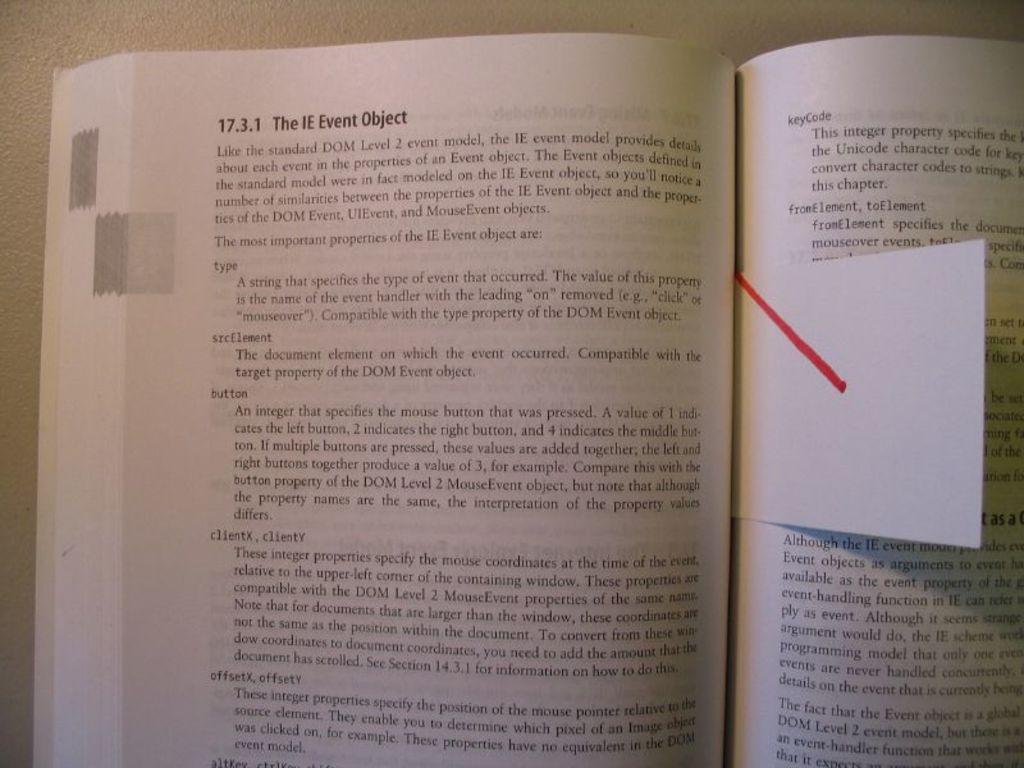Provide a one-sentence caption for the provided image. A book is opened and bookmarked on a page about The IE Event Object. 